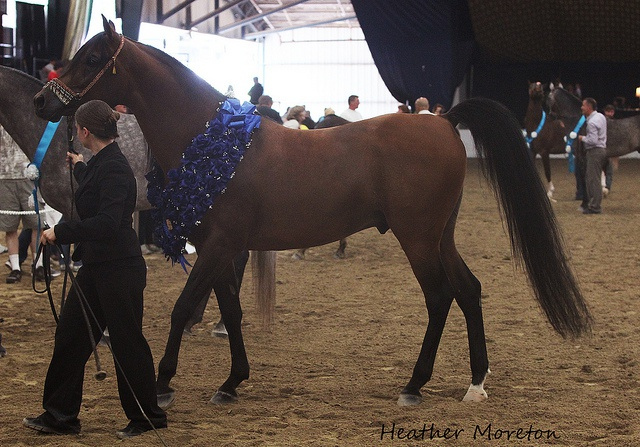Describe the objects in this image and their specific colors. I can see horse in purple, black, gray, and maroon tones, people in purple, black, gray, and maroon tones, horse in purple, black, and gray tones, horse in purple, black, gray, and darkgray tones, and people in purple, gray, darkgray, and black tones in this image. 